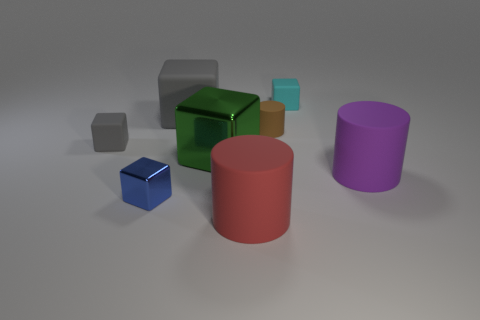Subtract all big cylinders. How many cylinders are left? 1 Subtract all blue blocks. How many blocks are left? 4 Subtract 3 blocks. How many blocks are left? 2 Add 1 gray blocks. How many objects exist? 9 Subtract all cyan cubes. Subtract all red cylinders. How many cubes are left? 4 Subtract all cubes. How many objects are left? 3 Add 5 tiny blue matte cylinders. How many tiny blue matte cylinders exist? 5 Subtract 1 green cubes. How many objects are left? 7 Subtract all small blue cylinders. Subtract all blue objects. How many objects are left? 7 Add 2 metallic objects. How many metallic objects are left? 4 